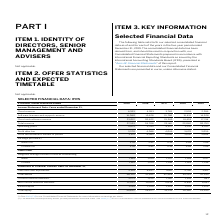According to Sap Ag's financial document, Where is more information on earnings per share provided? Note (C.6) to our Consolidated Financial Statements. The document states: "(1) See Note (C.6) to our Consolidated Financial Statements for more information on earnings per share...." Also, What do the current and non-current financial liabilities balances include? primarily bonds, private placements and bank loans.. The document states: "(2) The balances include primarily bonds, private placements and bank loans. See Note (E.3) to our Consolidated Financial Statements for more informat..." Also, In which years was total equity calculated? The document contains multiple relevant values: 2019, 2018, 2017, 2016, 2015. From the document: "€ millions, unless otherwise stated 2019 2018 2017 2016 2015 € millions, unless otherwise stated 2019 2018 2017 2016 2015 millions, unless otherwise s..." Additionally, In which year was the Basic earnings per share the largest? According to the financial document, 2018. The relevant text states: "€ millions, unless otherwise stated 2019 2018 2017 2016 2015..." Also, can you calculate: What was the change in issued capital in 2019 from 2018? I cannot find a specific answer to this question in the financial document. Also, can you calculate: What was the percentage change in issued capital in 2019 from 2018? I cannot find a specific answer to this question in the financial document. 